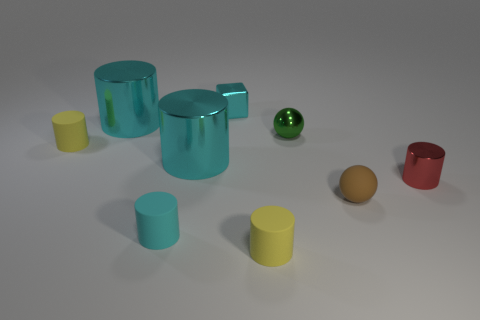How many cyan cylinders must be subtracted to get 1 cyan cylinders? 2 Subtract all red cylinders. How many cylinders are left? 5 Subtract all yellow cylinders. How many cylinders are left? 4 Subtract 3 cylinders. How many cylinders are left? 3 Subtract all yellow balls. Subtract all cyan cylinders. How many balls are left? 2 Subtract all red spheres. How many cyan cylinders are left? 3 Subtract all green shiny things. Subtract all green spheres. How many objects are left? 7 Add 7 tiny cyan matte cylinders. How many tiny cyan matte cylinders are left? 8 Add 7 tiny green spheres. How many tiny green spheres exist? 8 Subtract 1 cyan blocks. How many objects are left? 8 